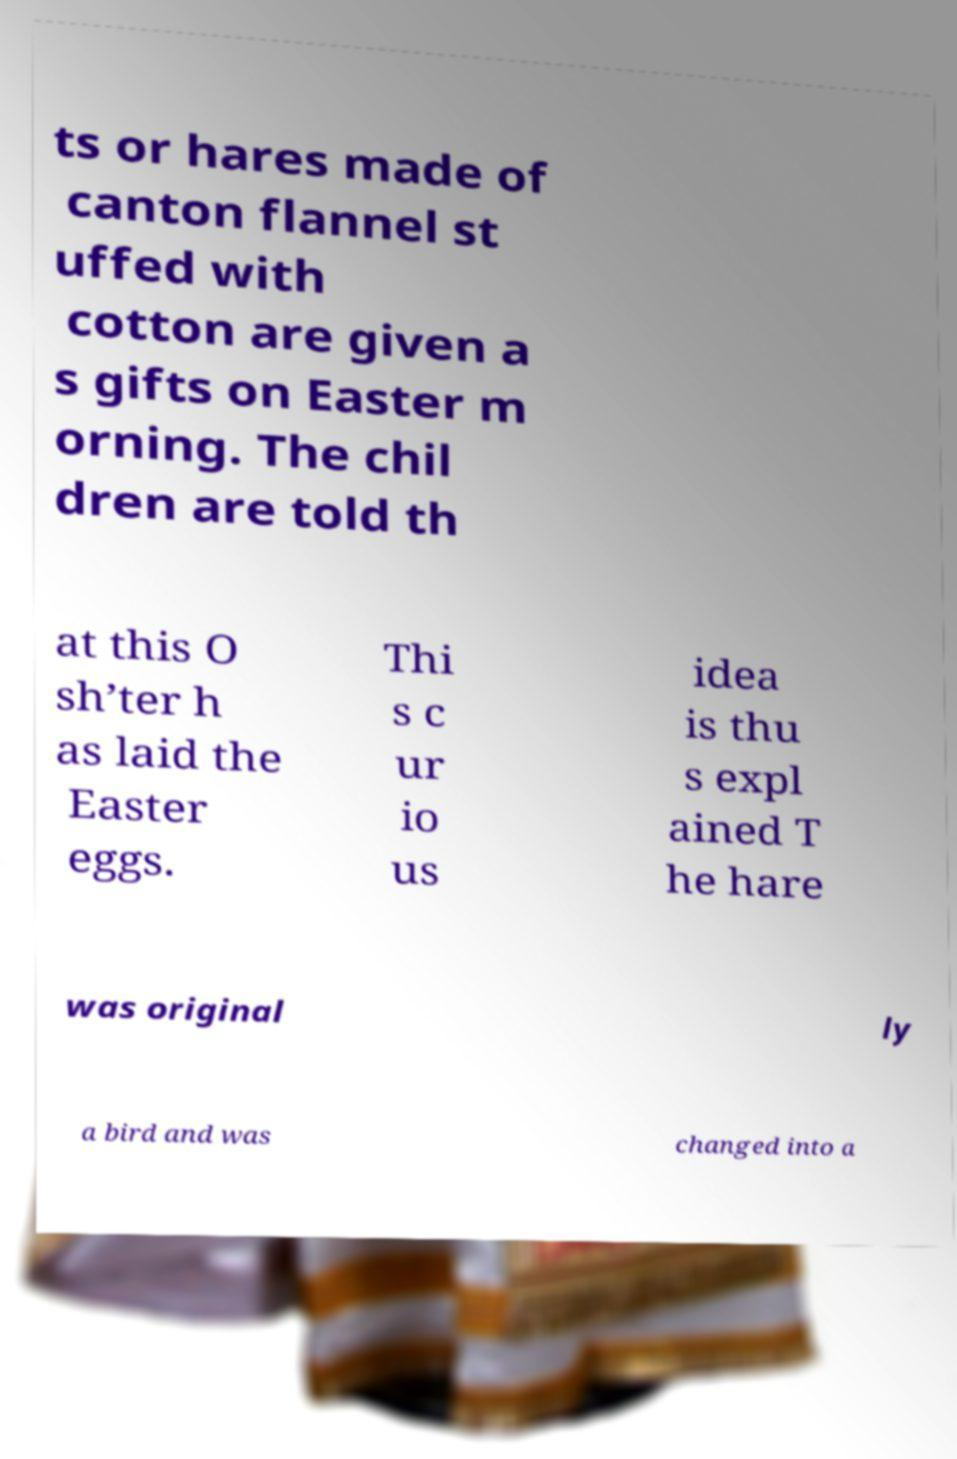There's text embedded in this image that I need extracted. Can you transcribe it verbatim? ts or hares made of canton flannel st uffed with cotton are given a s gifts on Easter m orning. The chil dren are told th at this O sh’ter h as laid the Easter eggs. Thi s c ur io us idea is thu s expl ained T he hare was original ly a bird and was changed into a 